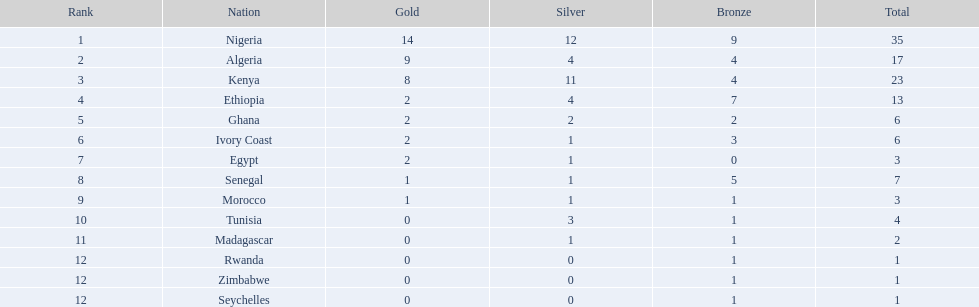Give me the full table as a dictionary. {'header': ['Rank', 'Nation', 'Gold', 'Silver', 'Bronze', 'Total'], 'rows': [['1', 'Nigeria', '14', '12', '9', '35'], ['2', 'Algeria', '9', '4', '4', '17'], ['3', 'Kenya', '8', '11', '4', '23'], ['4', 'Ethiopia', '2', '4', '7', '13'], ['5', 'Ghana', '2', '2', '2', '6'], ['6', 'Ivory Coast', '2', '1', '3', '6'], ['7', 'Egypt', '2', '1', '0', '3'], ['8', 'Senegal', '1', '1', '5', '7'], ['9', 'Morocco', '1', '1', '1', '3'], ['10', 'Tunisia', '0', '3', '1', '4'], ['11', 'Madagascar', '0', '1', '1', '2'], ['12', 'Rwanda', '0', '0', '1', '1'], ['12', 'Zimbabwe', '0', '0', '1', '1'], ['12', 'Seychelles', '0', '0', '1', '1']]} Total number of bronze medals nigeria earned? 9. 